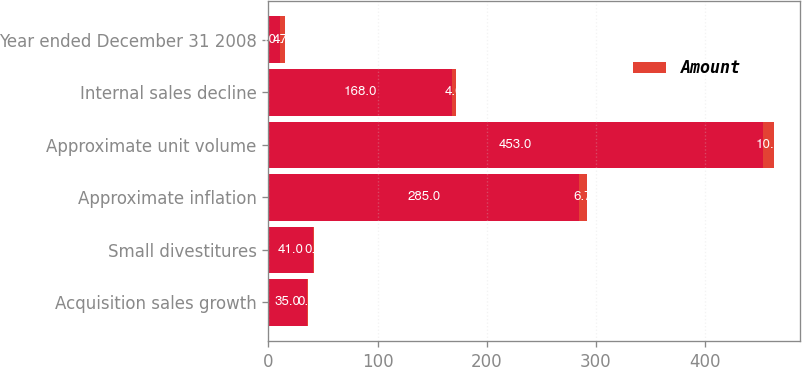<chart> <loc_0><loc_0><loc_500><loc_500><stacked_bar_chart><ecel><fcel>Acquisition sales growth<fcel>Small divestitures<fcel>Approximate inflation<fcel>Approximate unit volume<fcel>Internal sales decline<fcel>Year ended December 31 2008<nl><fcel>nan<fcel>35<fcel>41<fcel>285<fcel>453<fcel>168<fcel>10.7<nl><fcel>Amount<fcel>0.8<fcel>0.9<fcel>6.7<fcel>10.7<fcel>4<fcel>4.1<nl></chart> 